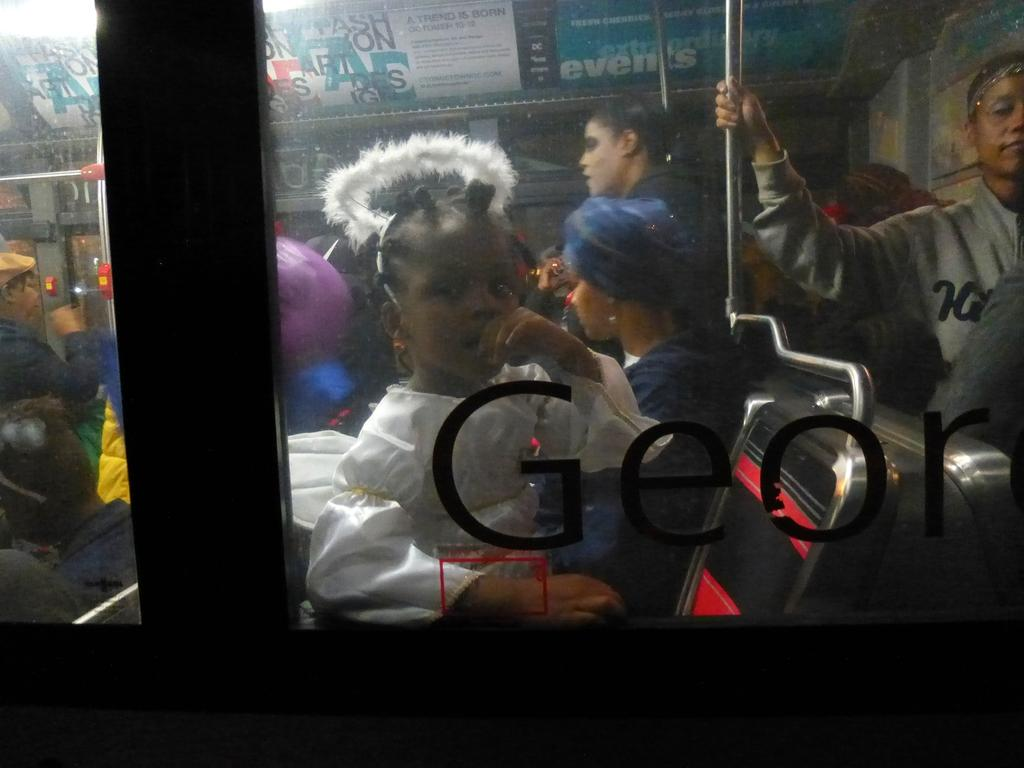What is the main feature of the image? The main feature of the image is text on a glass surface. What can be seen through the glass? People are visible through the glass. What objects are present in the scene? Rods and boards are present in the scene. How many beds are visible in the image? There are no beds present in the image. What type of poison is being used on the nerve in the image? There is no mention of poison or nerves in the image; it features text on a glass surface with people visible through it, along with rods and boards. 